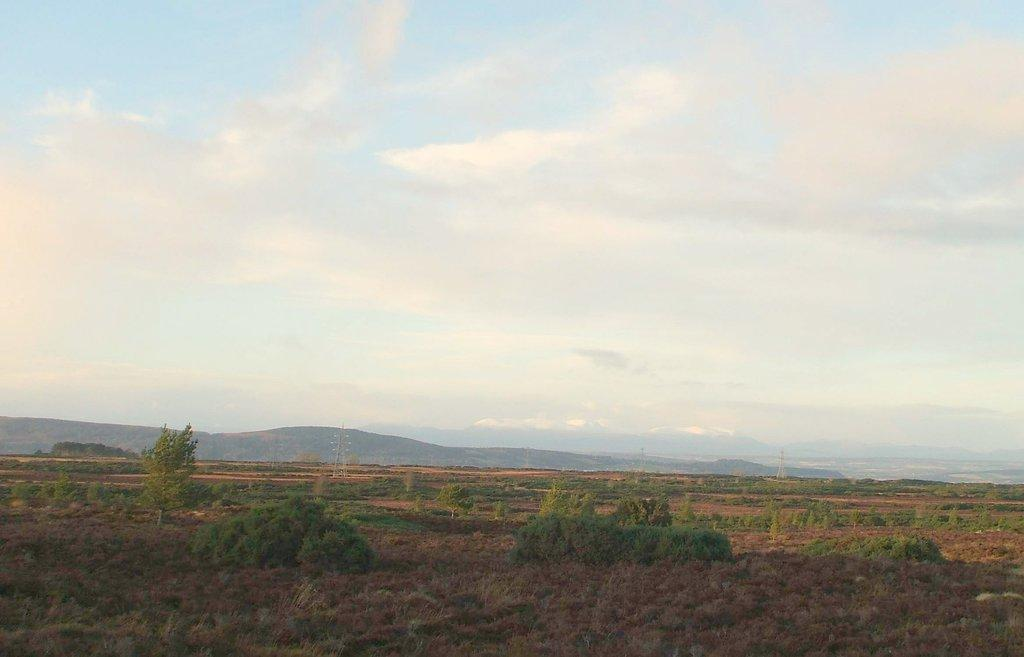What type of natural elements can be seen in the image? There are trees and hills visible in the image. What man-made structures are present in the image? Electric steel poles can be seen in the image. What is visible at the top of the image? The sky is visible at the top of the image. What is the condition of the sky in the image? The sky appears to be cloudy in the image. What type of answer can be seen written on the trees in the image? There are no answers written on the trees in the image; it features trees, hills, and electric steel poles. Can you tell me how many cracks are visible on the hills in the image? There is no mention of cracks on the hills in the image; it only describes the presence of trees, hills, electric steel poles, and a cloudy sky. 